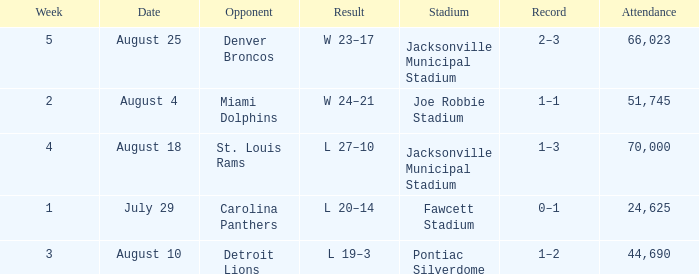WHEN has a Result of w 23–17? August 25. 